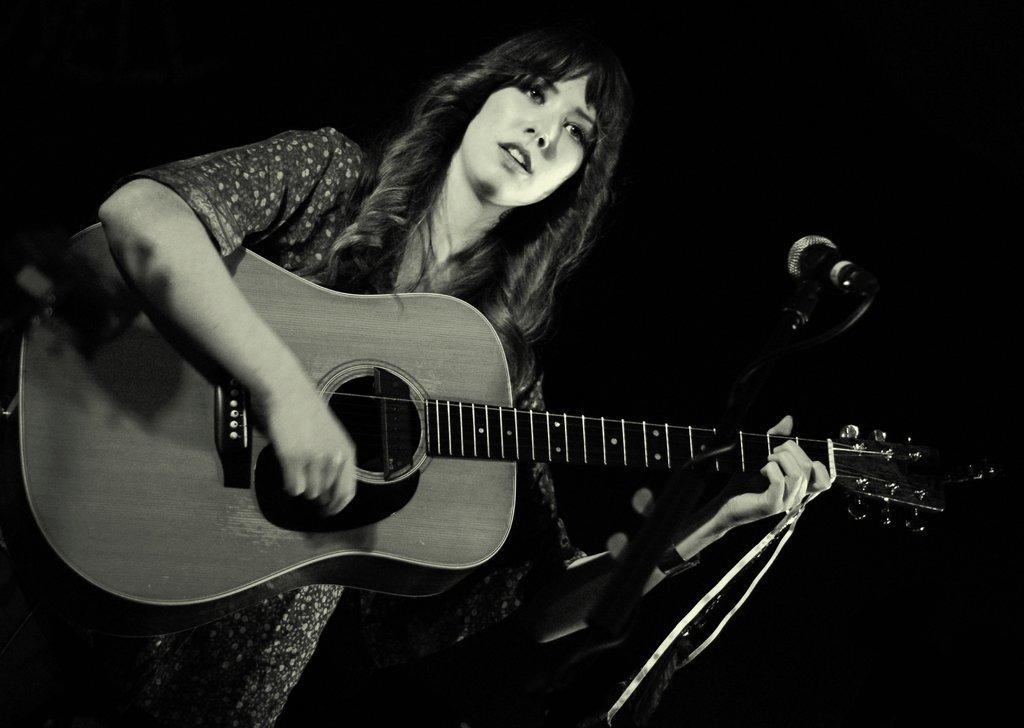Could you give a brief overview of what you see in this image? A lady is standing and playing the guitar with her hands. 